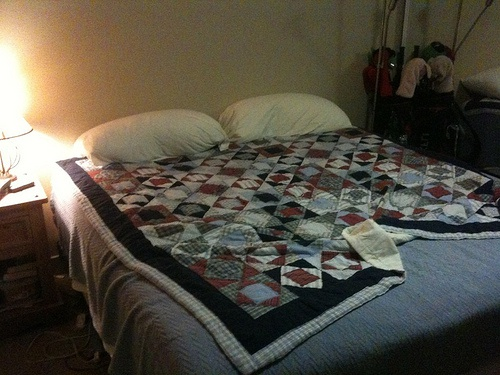Describe the objects in this image and their specific colors. I can see a bed in tan, black, gray, and darkgray tones in this image. 